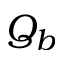<formula> <loc_0><loc_0><loc_500><loc_500>Q _ { b }</formula> 